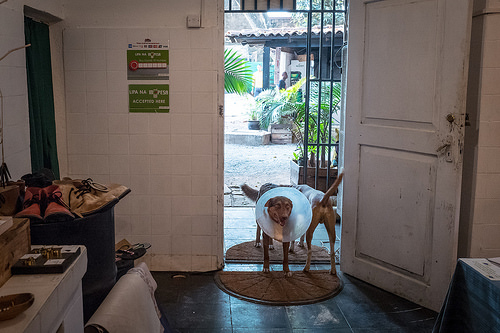<image>
Is the cone on the dog? Yes. Looking at the image, I can see the cone is positioned on top of the dog, with the dog providing support. Where is the dog in relation to the door? Is it to the right of the door? No. The dog is not to the right of the door. The horizontal positioning shows a different relationship. 